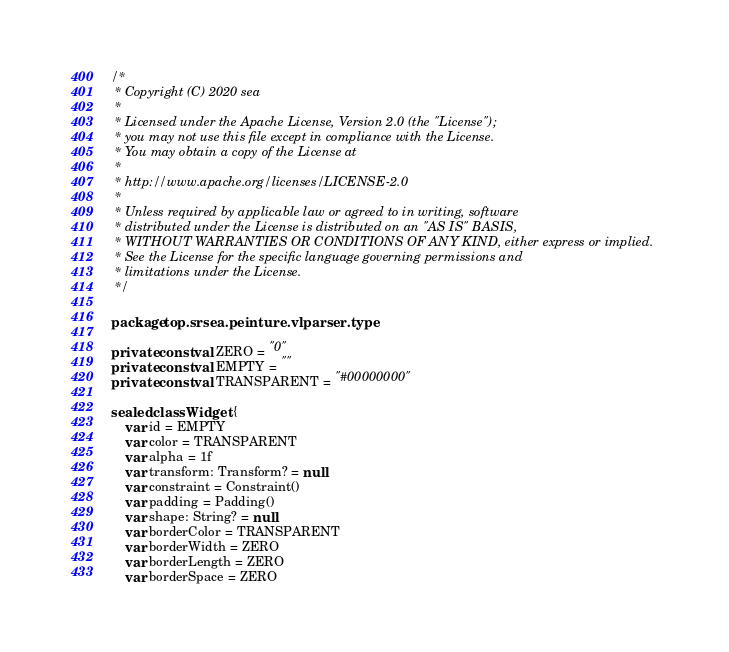<code> <loc_0><loc_0><loc_500><loc_500><_Kotlin_>/*
 * Copyright (C) 2020 sea
 *
 * Licensed under the Apache License, Version 2.0 (the "License");
 * you may not use this file except in compliance with the License.
 * You may obtain a copy of the License at
 *
 * http://www.apache.org/licenses/LICENSE-2.0
 *
 * Unless required by applicable law or agreed to in writing, software
 * distributed under the License is distributed on an "AS IS" BASIS,
 * WITHOUT WARRANTIES OR CONDITIONS OF ANY KIND, either express or implied.
 * See the License for the specific language governing permissions and
 * limitations under the License.
 */

package top.srsea.peinture.vlparser.type

private const val ZERO = "0"
private const val EMPTY = ""
private const val TRANSPARENT = "#00000000"

sealed class Widget {
    var id = EMPTY
    var color = TRANSPARENT
    var alpha = 1f
    var transform: Transform? = null
    var constraint = Constraint()
    var padding = Padding()
    var shape: String? = null
    var borderColor = TRANSPARENT
    var borderWidth = ZERO
    var borderLength = ZERO
    var borderSpace = ZERO</code> 